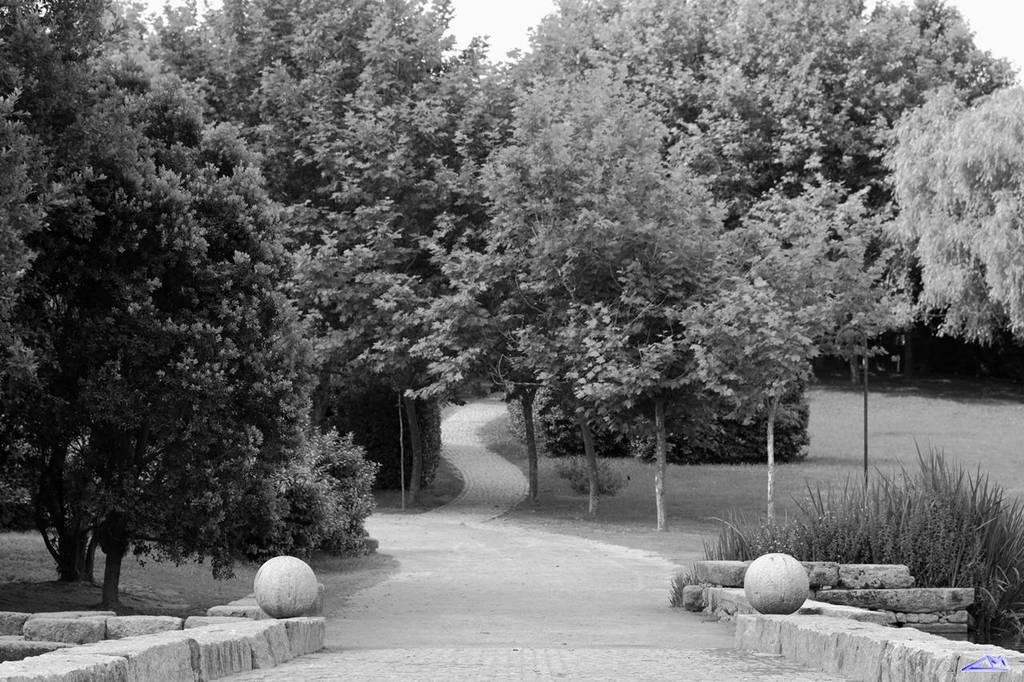What is the color scheme of the image? The image is black and white. What can be seen on the ground in the image? There is a pathway and stones present in the image. What type of vegetation is visible in the image? Grass and plants are visible in the image. What is the background of the image? There is a group of trees and the sky is visible in the image. What type of suit is the minister wearing in the image? There is no minister or suit present in the image. Can you tell me how many donkeys are grazing in the grass in the image? There are no donkeys present in the image; only plants and trees are visible. 